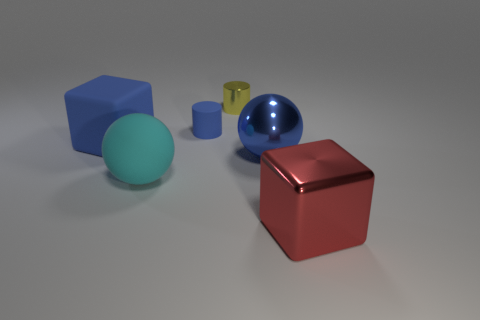Can you propose a narrative or backstory for the arrangement of these objects? Certainly! One might imagine these objects as characters in a silent play set in an otherworldly gallery. The large red cube could symbolize a stalwart guardian, standing firm and resolute. Its glossy sheen indicates an unyielding spirit. Nearby, the large blue sphere might represent a wanderer from afar, curious and bright, reflecting upon its surroundings as it seeks new experiences. The yellow cylinder, with its simpler texture, could be a wise elder, calm and collected, while the turquoise sphere might be a youthful apprentice, eager but still learning the depths of its own shine. Together, they form a tableau of a mystical realm where inanimate forms embody living qualities. 